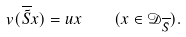<formula> <loc_0><loc_0><loc_500><loc_500>v ( \overline { \tilde { S } } x ) = u x \quad ( x \in { \mathcal { D } } _ { \overline { \tilde { S } } } ) .</formula> 